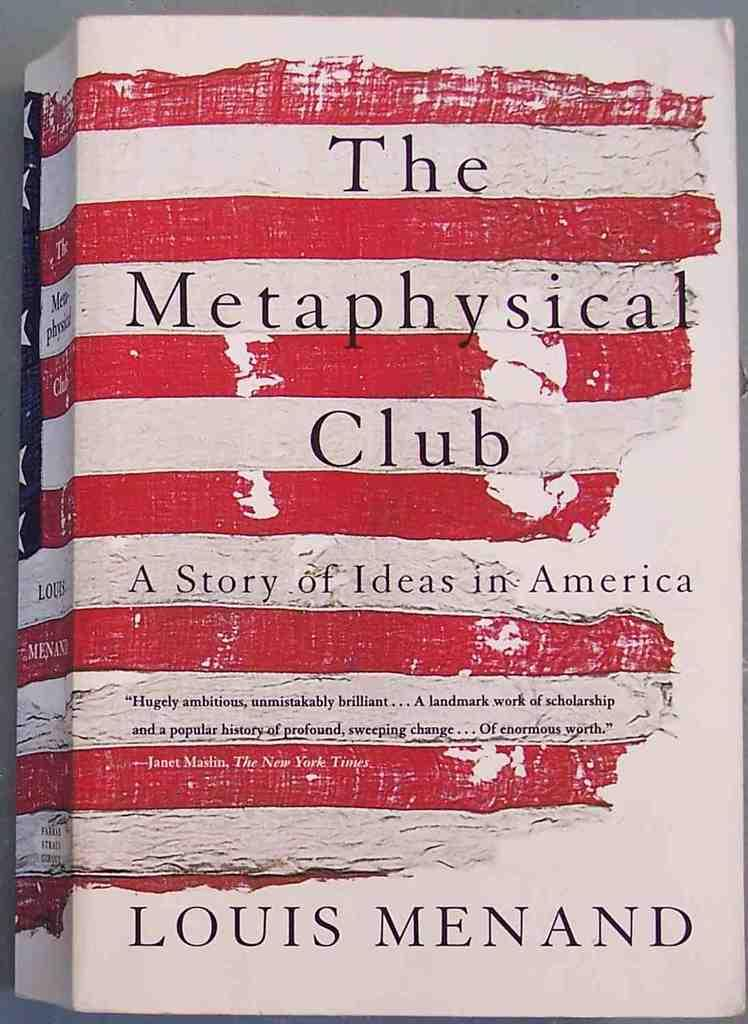What object is placed on a surface in the image? There is a book placed on a surface in the image. Can you describe the book's position or orientation in the image? The book is placed on a surface, but the specific position or orientation cannot be determined from the provided facts. What might the book be about, based on its presence in the image? The content of the book cannot be determined from the image alone. What type of rose can be seen growing near the market gate in the image? There is no rose, market, or gate present in the image; it only features a book placed on a surface. 